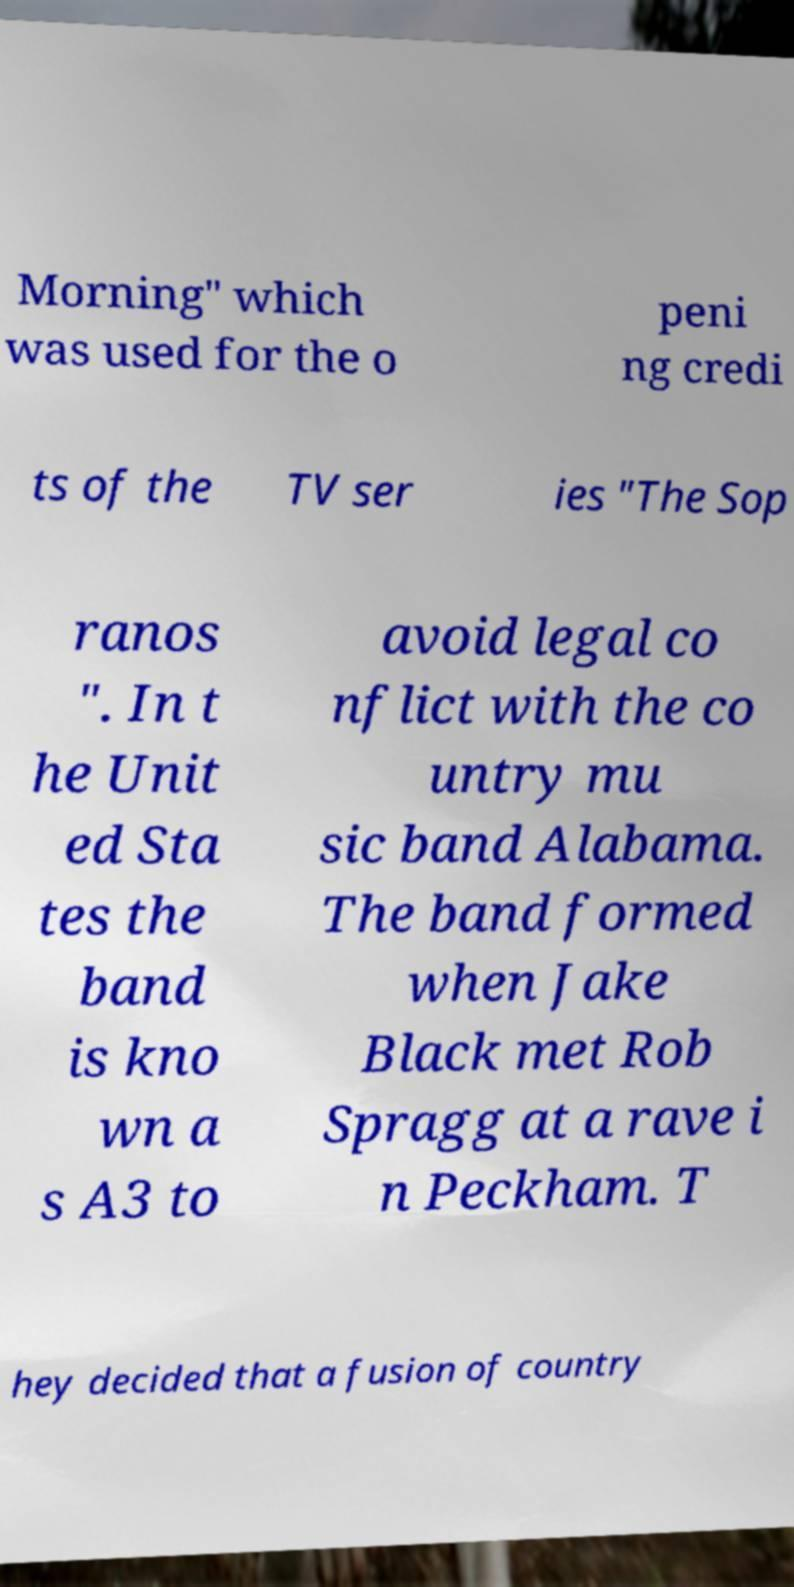I need the written content from this picture converted into text. Can you do that? Morning" which was used for the o peni ng credi ts of the TV ser ies "The Sop ranos ". In t he Unit ed Sta tes the band is kno wn a s A3 to avoid legal co nflict with the co untry mu sic band Alabama. The band formed when Jake Black met Rob Spragg at a rave i n Peckham. T hey decided that a fusion of country 